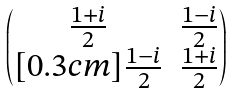Convert formula to latex. <formula><loc_0><loc_0><loc_500><loc_500>\begin{pmatrix} \frac { 1 + i } { 2 } & \frac { 1 - i } { 2 } \\ [ 0 . 3 c m ] \frac { 1 - i } { 2 } & \frac { 1 + i } { 2 } \end{pmatrix}</formula> 